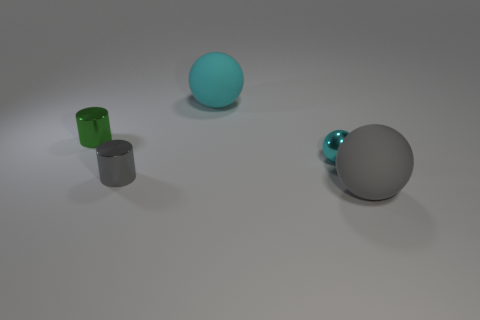Add 1 yellow balls. How many objects exist? 6 Subtract all cylinders. How many objects are left? 3 Add 2 tiny purple shiny things. How many tiny purple shiny things exist? 2 Subtract 0 brown blocks. How many objects are left? 5 Subtract all small shiny cylinders. Subtract all small gray cylinders. How many objects are left? 2 Add 1 cyan balls. How many cyan balls are left? 3 